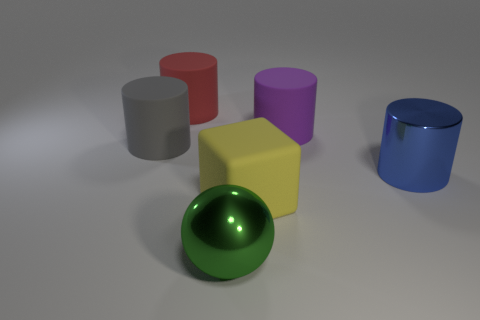Add 1 large brown rubber cylinders. How many objects exist? 7 Subtract all blocks. How many objects are left? 5 Subtract all purple spheres. Subtract all rubber cubes. How many objects are left? 5 Add 2 metallic cylinders. How many metallic cylinders are left? 3 Add 1 big red objects. How many big red objects exist? 2 Subtract 0 red balls. How many objects are left? 6 